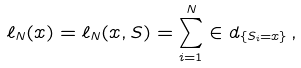<formula> <loc_0><loc_0><loc_500><loc_500>\ell _ { N } ( x ) = \ell _ { N } ( x , S ) = \sum _ { i = 1 } ^ { N } \in d _ { \{ S _ { i } = x \} } \, ,</formula> 